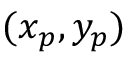<formula> <loc_0><loc_0><loc_500><loc_500>( x _ { p } , y _ { p } )</formula> 